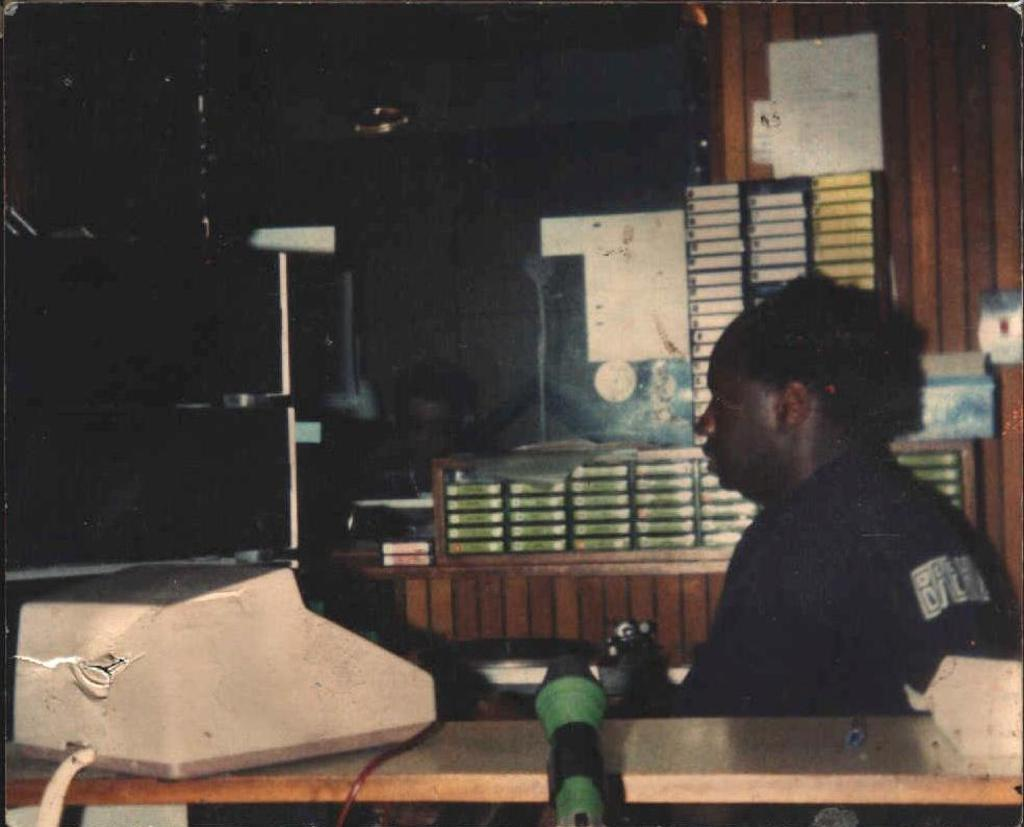Who or what is present in the image? There is a person in the image. What else can be seen in the image besides the person? There is a machine and objects in the image. What is the color of the wall in the background of the image? The wall in the background of the image is brown. How would you describe the overall appearance of the image? The image has a dark appearance. What type of competition is being held in the image? There is no competition present in the image. How is the drug being distributed in the image? There is no drug present in the image, so distribution cannot be determined. 